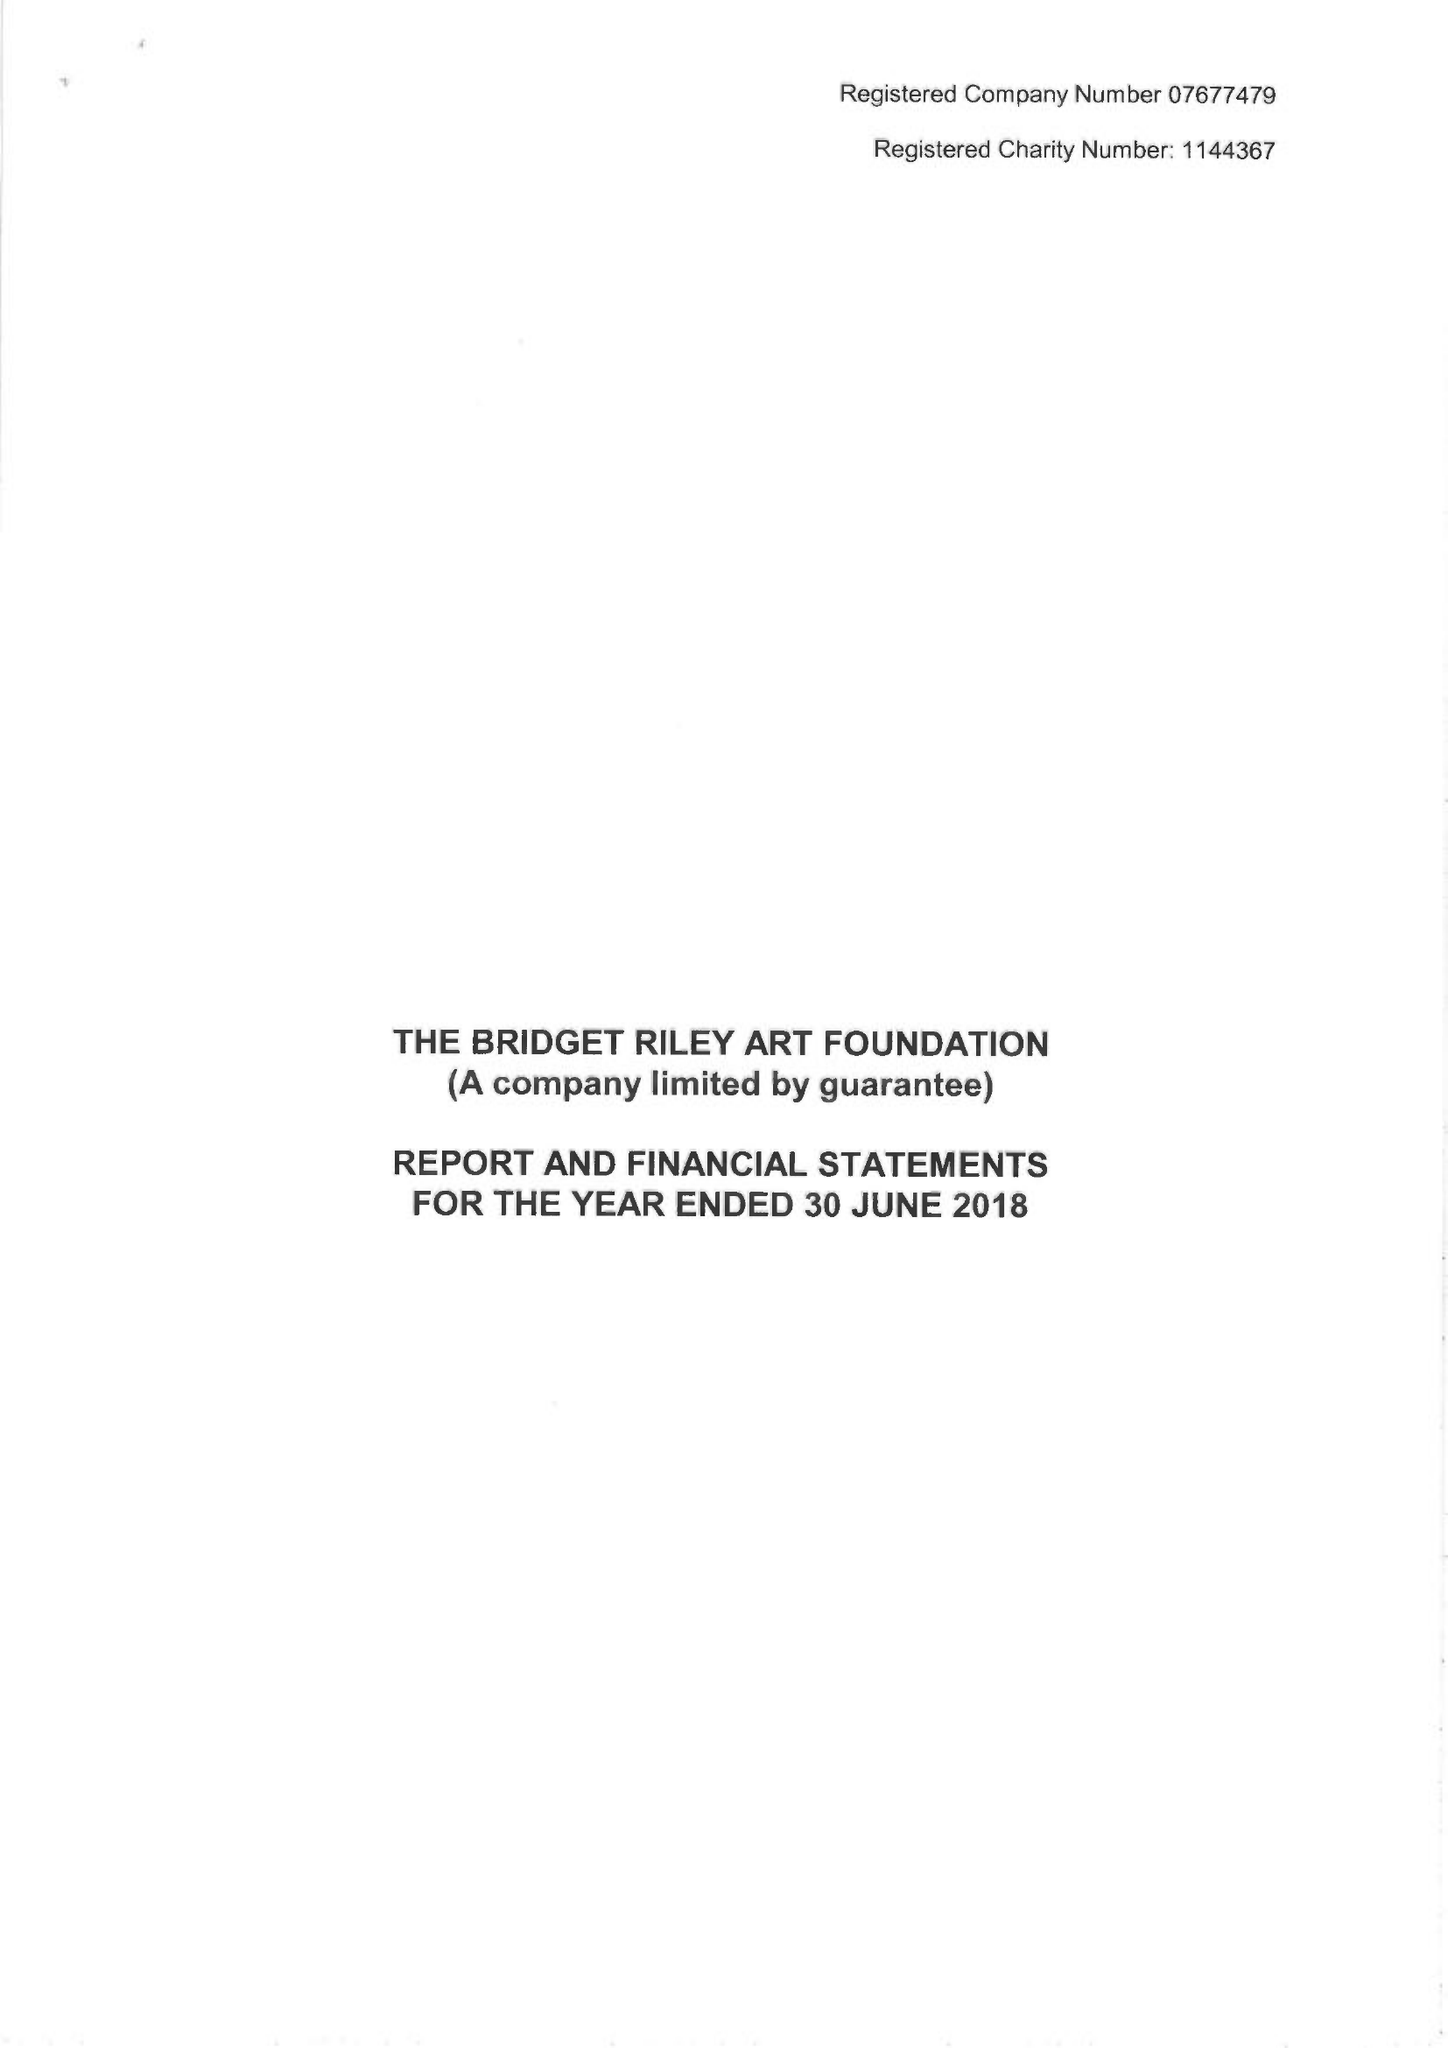What is the value for the spending_annually_in_british_pounds?
Answer the question using a single word or phrase. 448424.00 